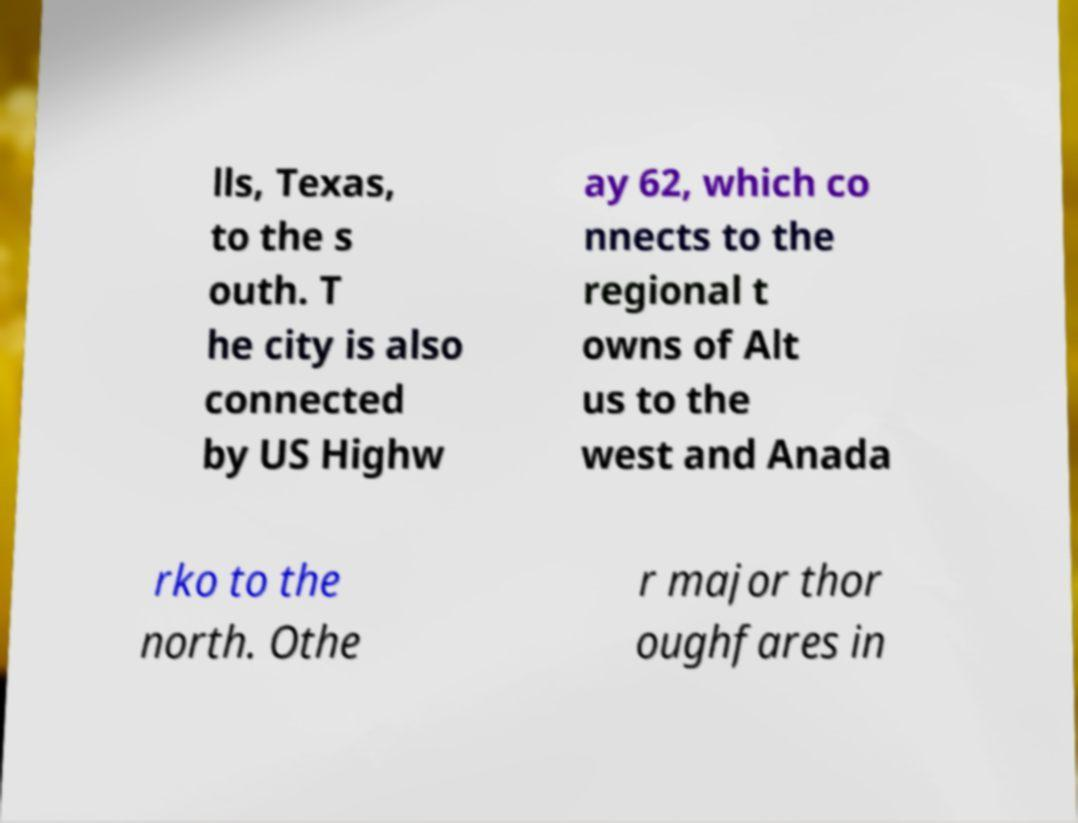For documentation purposes, I need the text within this image transcribed. Could you provide that? lls, Texas, to the s outh. T he city is also connected by US Highw ay 62, which co nnects to the regional t owns of Alt us to the west and Anada rko to the north. Othe r major thor oughfares in 